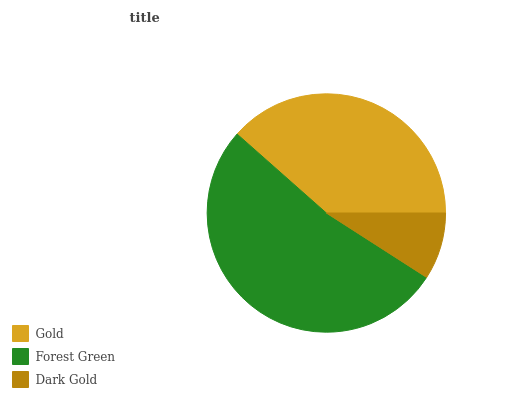Is Dark Gold the minimum?
Answer yes or no. Yes. Is Forest Green the maximum?
Answer yes or no. Yes. Is Forest Green the minimum?
Answer yes or no. No. Is Dark Gold the maximum?
Answer yes or no. No. Is Forest Green greater than Dark Gold?
Answer yes or no. Yes. Is Dark Gold less than Forest Green?
Answer yes or no. Yes. Is Dark Gold greater than Forest Green?
Answer yes or no. No. Is Forest Green less than Dark Gold?
Answer yes or no. No. Is Gold the high median?
Answer yes or no. Yes. Is Gold the low median?
Answer yes or no. Yes. Is Dark Gold the high median?
Answer yes or no. No. Is Dark Gold the low median?
Answer yes or no. No. 